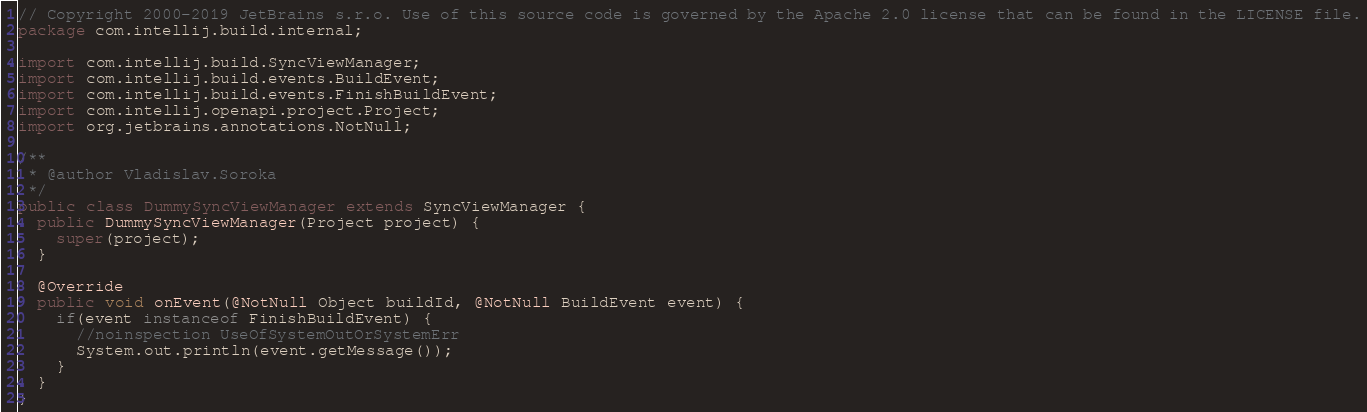Convert code to text. <code><loc_0><loc_0><loc_500><loc_500><_Java_>// Copyright 2000-2019 JetBrains s.r.o. Use of this source code is governed by the Apache 2.0 license that can be found in the LICENSE file.
package com.intellij.build.internal;

import com.intellij.build.SyncViewManager;
import com.intellij.build.events.BuildEvent;
import com.intellij.build.events.FinishBuildEvent;
import com.intellij.openapi.project.Project;
import org.jetbrains.annotations.NotNull;

/**
 * @author Vladislav.Soroka
 */
public class DummySyncViewManager extends SyncViewManager {
  public DummySyncViewManager(Project project) {
    super(project);
  }

  @Override
  public void onEvent(@NotNull Object buildId, @NotNull BuildEvent event) {
    if(event instanceof FinishBuildEvent) {
      //noinspection UseOfSystemOutOrSystemErr
      System.out.println(event.getMessage());
    }
  }
}
</code> 